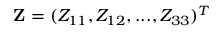Convert formula to latex. <formula><loc_0><loc_0><loc_500><loc_500>{ Z } = ( Z _ { 1 1 } , Z _ { 1 2 } , \dots , Z _ { 3 3 } ) ^ { T }</formula> 